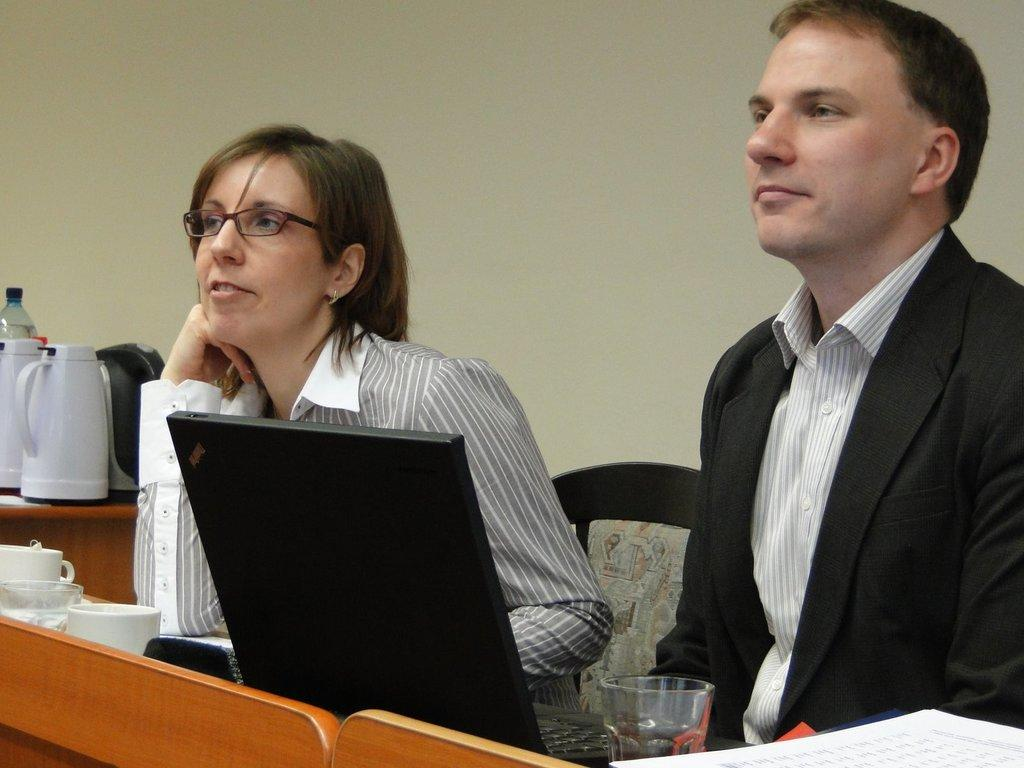What can be seen in the background of the image? There is a wall in the image. What type of furniture is visible in the image? There are chairs in the image. What are the people in the image doing? Two people are sitting on the chairs. What is on the table in the image? There is a laptop and cups on the table. Can you see a tin can on the table in the image? There is no tin can present on the table in the image. Is there a rifle leaning against the wall in the image? There is no rifle present in the image. 